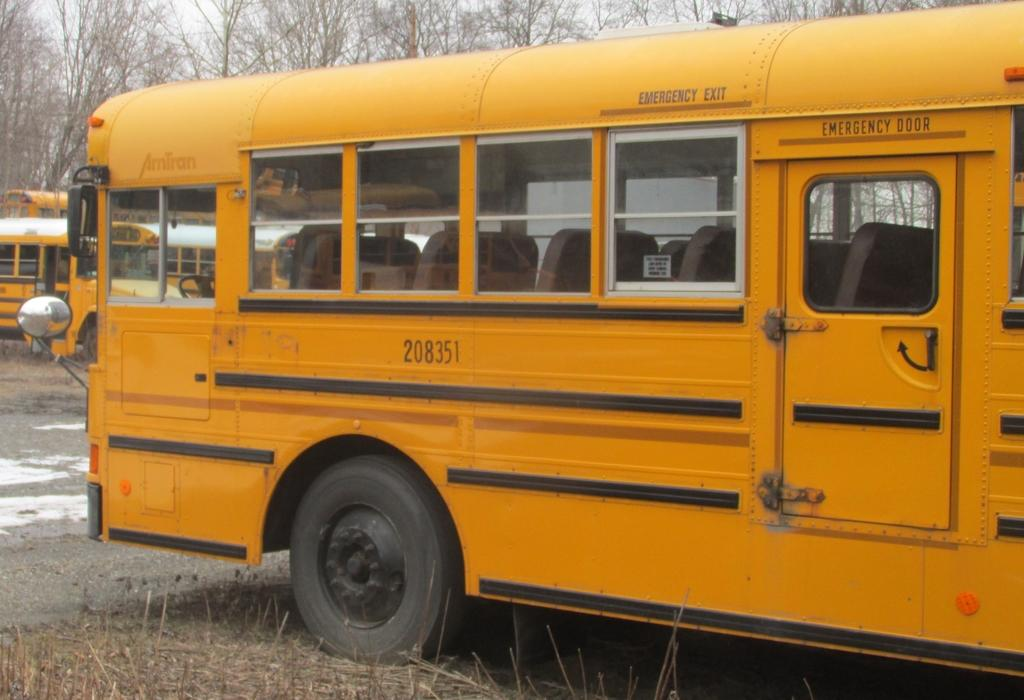What type of vehicles can be seen in the image? There are buses in the image. What is on the ground in the image? There is grass on the ground in the image. What can be seen in the background of the image? There are trees in the background of the image. What type of coat is draped over the bus in the image? There is no coat draped over the bus in the image; it is a vehicle, not a person. 